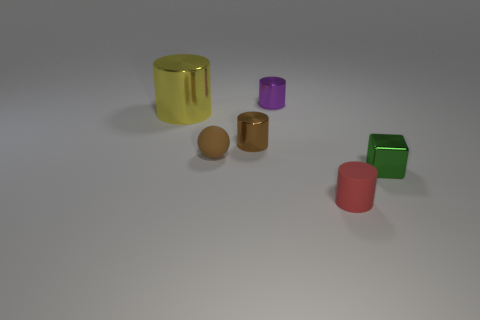Subtract all small red matte cylinders. How many cylinders are left? 3 Subtract all purple cylinders. How many cylinders are left? 3 Add 1 tiny blue rubber cylinders. How many objects exist? 7 Subtract all cylinders. How many objects are left? 2 Subtract 1 cubes. How many cubes are left? 0 Subtract 1 purple cylinders. How many objects are left? 5 Subtract all red balls. Subtract all gray cylinders. How many balls are left? 1 Subtract all cyan blocks. How many yellow spheres are left? 0 Subtract all tiny red objects. Subtract all purple objects. How many objects are left? 4 Add 4 balls. How many balls are left? 5 